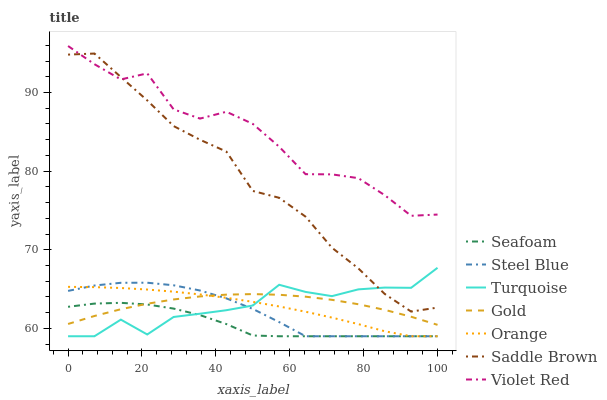Does Seafoam have the minimum area under the curve?
Answer yes or no. Yes. Does Violet Red have the maximum area under the curve?
Answer yes or no. Yes. Does Gold have the minimum area under the curve?
Answer yes or no. No. Does Gold have the maximum area under the curve?
Answer yes or no. No. Is Orange the smoothest?
Answer yes or no. Yes. Is Violet Red the roughest?
Answer yes or no. Yes. Is Gold the smoothest?
Answer yes or no. No. Is Gold the roughest?
Answer yes or no. No. Does Turquoise have the lowest value?
Answer yes or no. Yes. Does Gold have the lowest value?
Answer yes or no. No. Does Violet Red have the highest value?
Answer yes or no. Yes. Does Gold have the highest value?
Answer yes or no. No. Is Orange less than Violet Red?
Answer yes or no. Yes. Is Saddle Brown greater than Steel Blue?
Answer yes or no. Yes. Does Orange intersect Steel Blue?
Answer yes or no. Yes. Is Orange less than Steel Blue?
Answer yes or no. No. Is Orange greater than Steel Blue?
Answer yes or no. No. Does Orange intersect Violet Red?
Answer yes or no. No. 